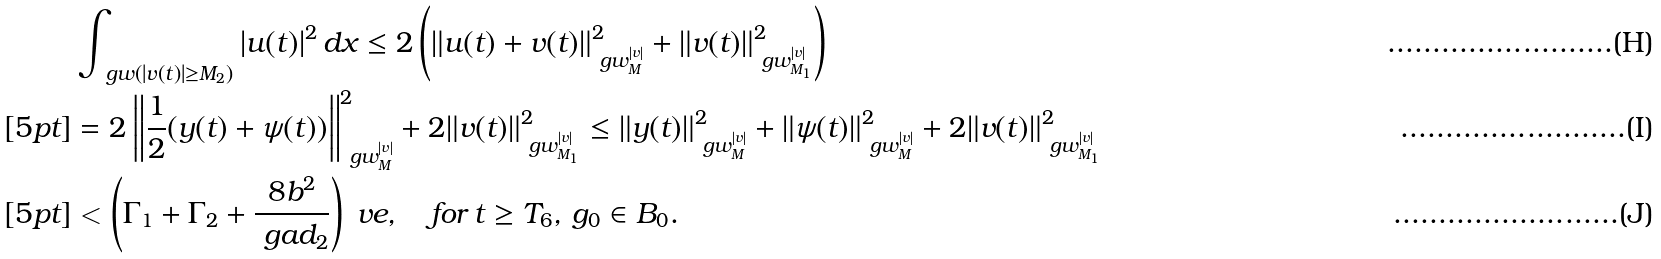<formula> <loc_0><loc_0><loc_500><loc_500>& \int _ { \ g w ( | v ( t ) | \geq M _ { 2 } ) } | u ( t ) | ^ { 2 } \, d x \leq 2 \left ( \| u ( t ) + v ( t ) \| _ { \ g w _ { M } ^ { | v | } } ^ { 2 } + \| v ( t ) \| _ { \ g w _ { M _ { 1 } } ^ { | v | } } ^ { 2 } \right ) \\ [ 5 p t ] & = 2 \left \| \frac { 1 } { 2 } ( y ( t ) + \psi ( t ) ) \right \| _ { \ g w _ { M } ^ { | v | } } ^ { 2 } + 2 \| v ( t ) \| _ { \ g w _ { M _ { 1 } } ^ { | v | } } ^ { 2 } \leq \| y ( t ) \| _ { \ g w _ { M } ^ { | v | } } ^ { 2 } + \| \psi ( t ) \| _ { \ g w _ { M } ^ { | v | } } ^ { 2 } + 2 \| v ( t ) \| _ { \ g w _ { M _ { 1 } } ^ { | v | } } ^ { 2 } \\ [ 5 p t ] & < \left ( \Gamma _ { 1 } + \Gamma _ { 2 } + \frac { 8 b ^ { 2 } } { \ g a d _ { 2 } } \right ) \ v e , \quad f o r \, t \geq T _ { 6 } , \, g _ { 0 } \in B _ { 0 } .</formula> 